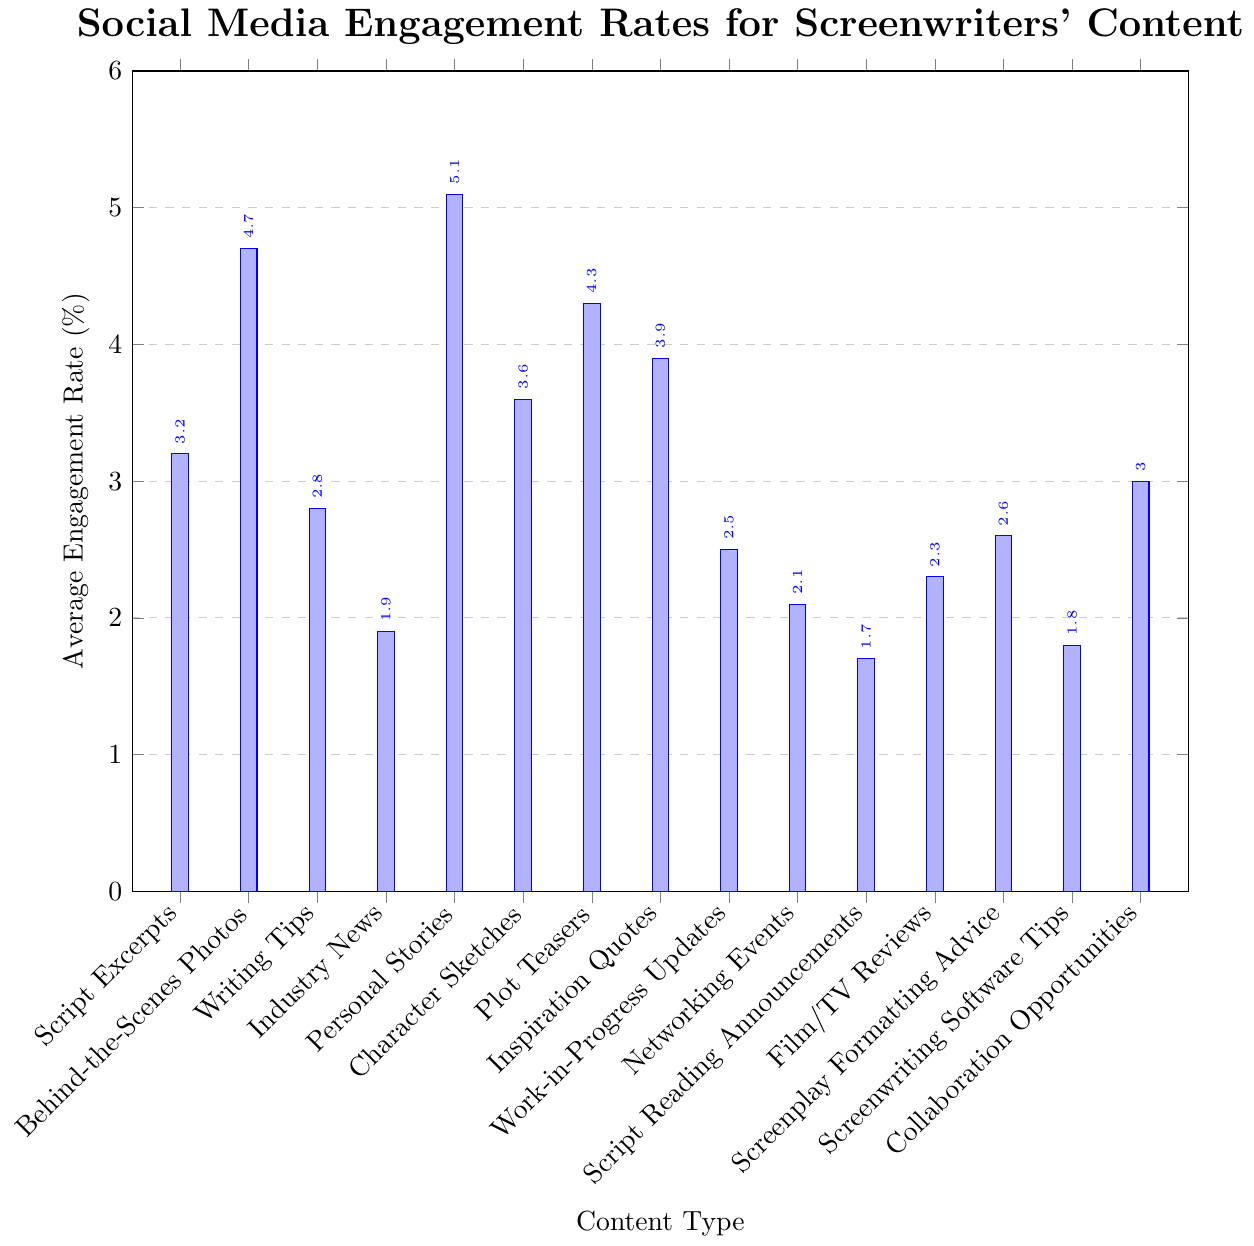What type of content has the highest average engagement rate? Identify the content type with the tallest bar in the figure, indicating the highest percentage value. The tallest bar corresponds to "Personal Stories" with an engagement rate of 5.1%.
Answer: Personal Stories Which content type has a higher engagement rate, "Script Excerpts" or "Writing Tips"? Compare the heights of the bars representing "Script Excerpts" and "Writing Tips". "Script Excerpts" has an engagement rate of 3.2%, while "Writing Tips" has 2.8%.
Answer: Script Excerpts What's the total average engagement rate for "Plot Teasers" and "Inspiration Quotes"? Add the engagement rates of "Plot Teasers" (4.3%) and "Inspiration Quotes" (3.9%). The total is 4.3 + 3.9 = 8.2%.
Answer: 8.2% How many content types have an average engagement rate below 3%? Count the bars with heights corresponding to engagement rates below 3%. They include "Writing Tips" (2.8%), "Industry News" (1.9%), "Work-in-Progress Updates" (2.5%), "Networking Events" (2.1%), "Script Reading Announcements" (1.7%), "Film/TV Reviews" (2.3%), "Screenplay Formatting Advice" (2.6%), and "Screenwriting Software Tips" (1.8%). There are 8 such content types.
Answer: 8 What is the difference in average engagement rate between the highest and the lowest content types? Subtract the lowest engagement rate ("Script Reading Announcements" at 1.7%) from the highest engagement rate ("Personal Stories" at 5.1%). The difference is 5.1 - 1.7 = 3.4%.
Answer: 3.4% Which three content types have the closest average engagement rates? Examine the engagement rates and identify those with the smallest differences between them. "Script Excerpts" (3.2%), "Character Sketches" (3.6%), and "Collaboration Opportunities" (3.0%) are the closest, all within a 0.6% range.
Answer: Script Excerpts, Character Sketches, Collaboration Opportunities Which content type has a lower average engagement rate: "Film/TV Reviews" or "Networking Events"? Compare the engagement rates of "Film/TV Reviews" (2.3%) and "Networking Events" (2.1%).
Answer: Networking Events 